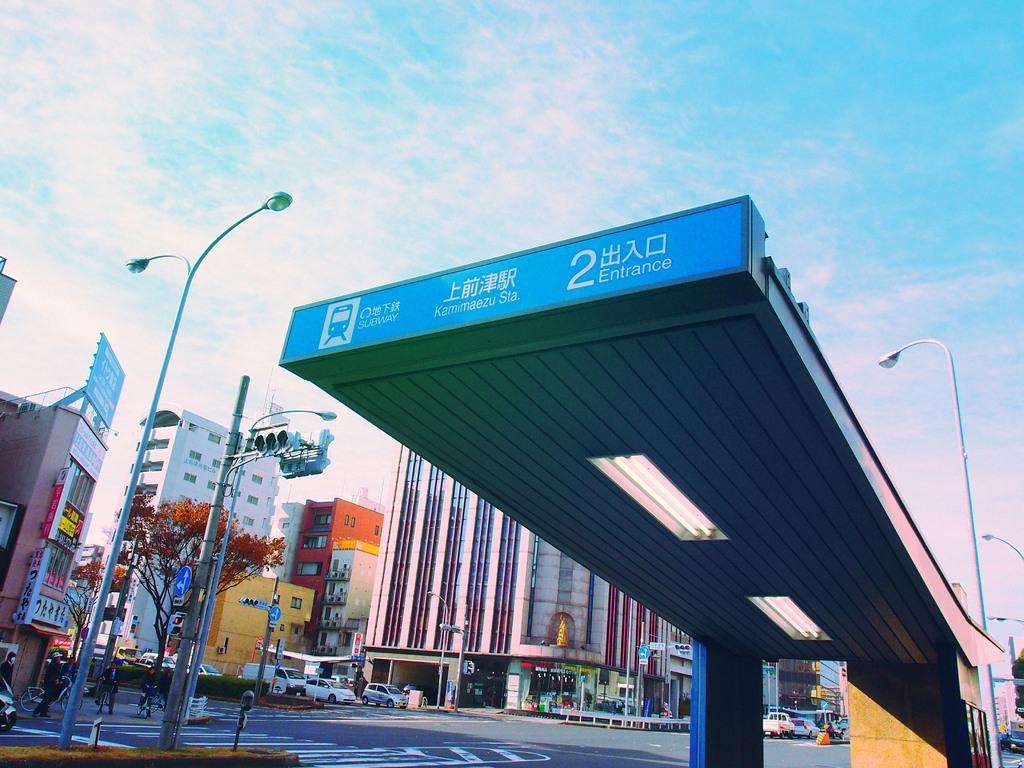How would you summarize this image in a sentence or two? This picture shows buildings and we see a tree and a few pole lights and we see a pole with traffic signal lights and we see few vehicles on the road and we see a blue cloudy sky. 